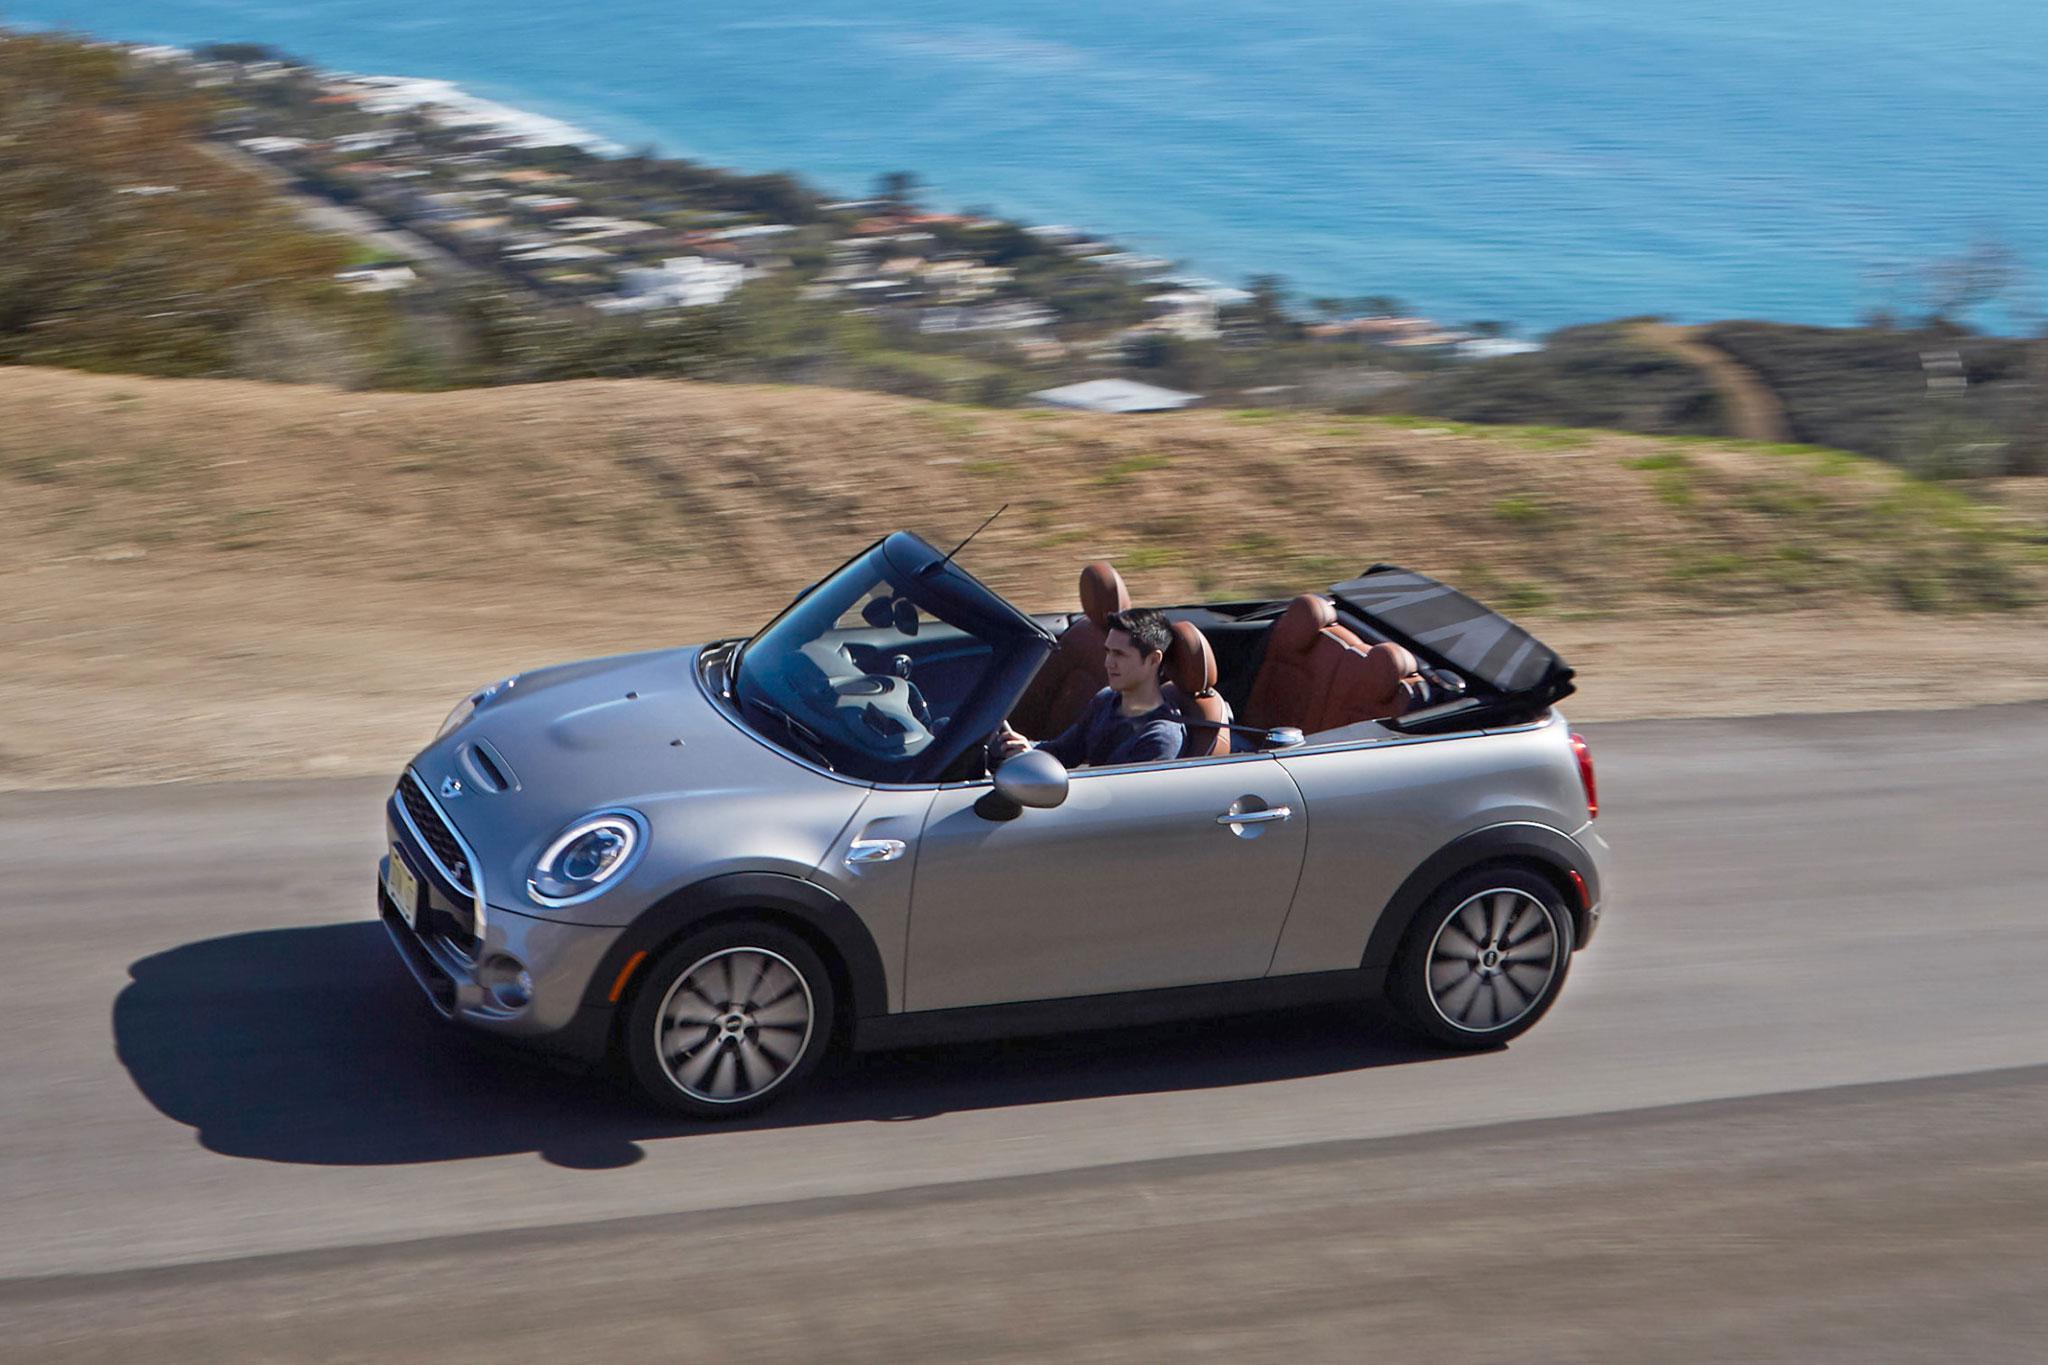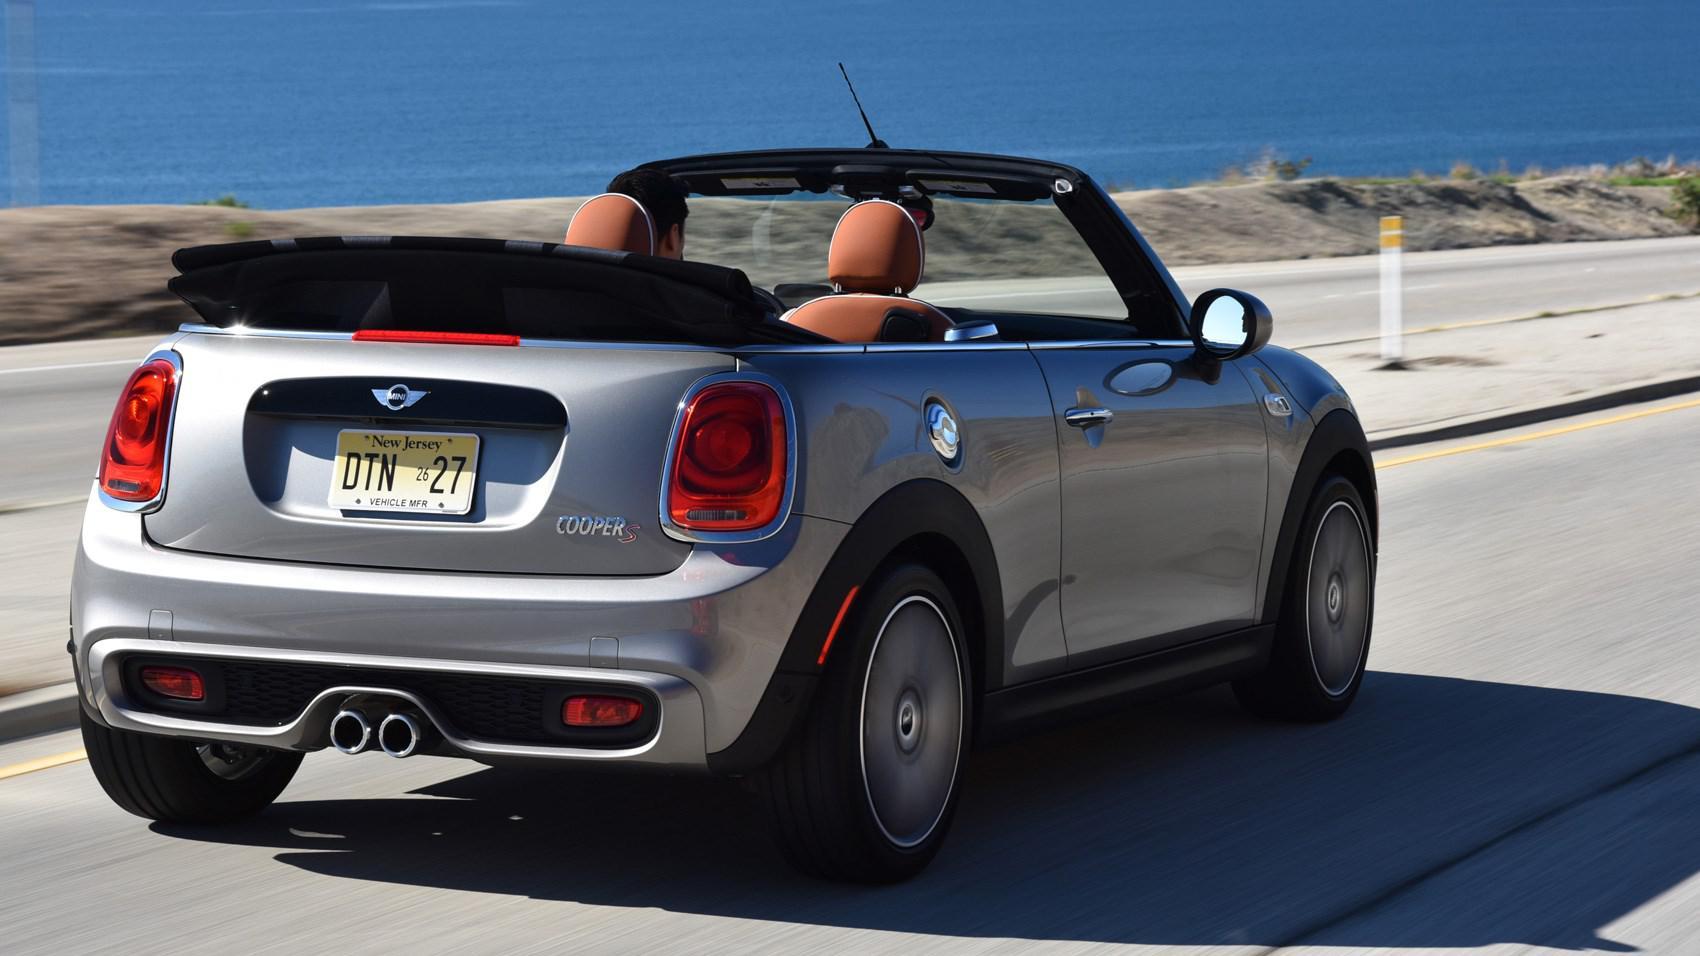The first image is the image on the left, the second image is the image on the right. Given the left and right images, does the statement "The silver convertibles in these images are currently being driven and are not parked." hold true? Answer yes or no. Yes. 